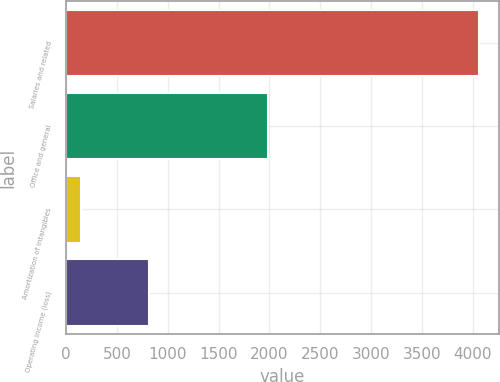<chart> <loc_0><loc_0><loc_500><loc_500><bar_chart><fcel>Salaries and related<fcel>Office and general<fcel>Amortization of intangibles<fcel>Operating income (loss)<nl><fcel>4056.4<fcel>1986.6<fcel>144.4<fcel>817.6<nl></chart> 